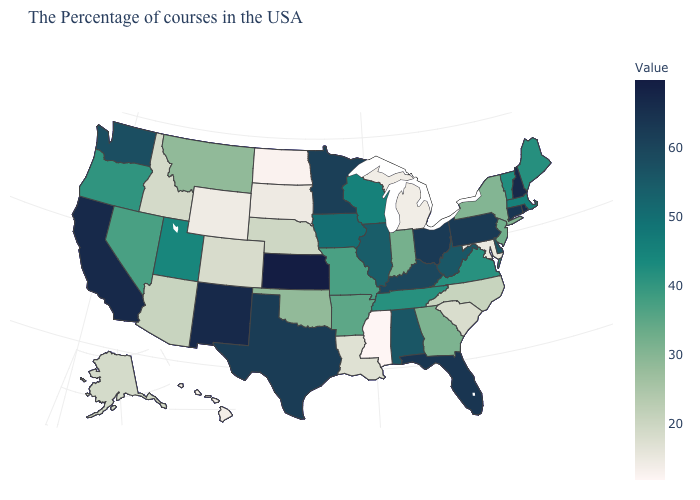Does Mississippi have the lowest value in the USA?
Write a very short answer. Yes. Among the states that border Wyoming , does Utah have the highest value?
Give a very brief answer. Yes. Which states hav the highest value in the Northeast?
Give a very brief answer. New Hampshire. Does the map have missing data?
Answer briefly. No. 